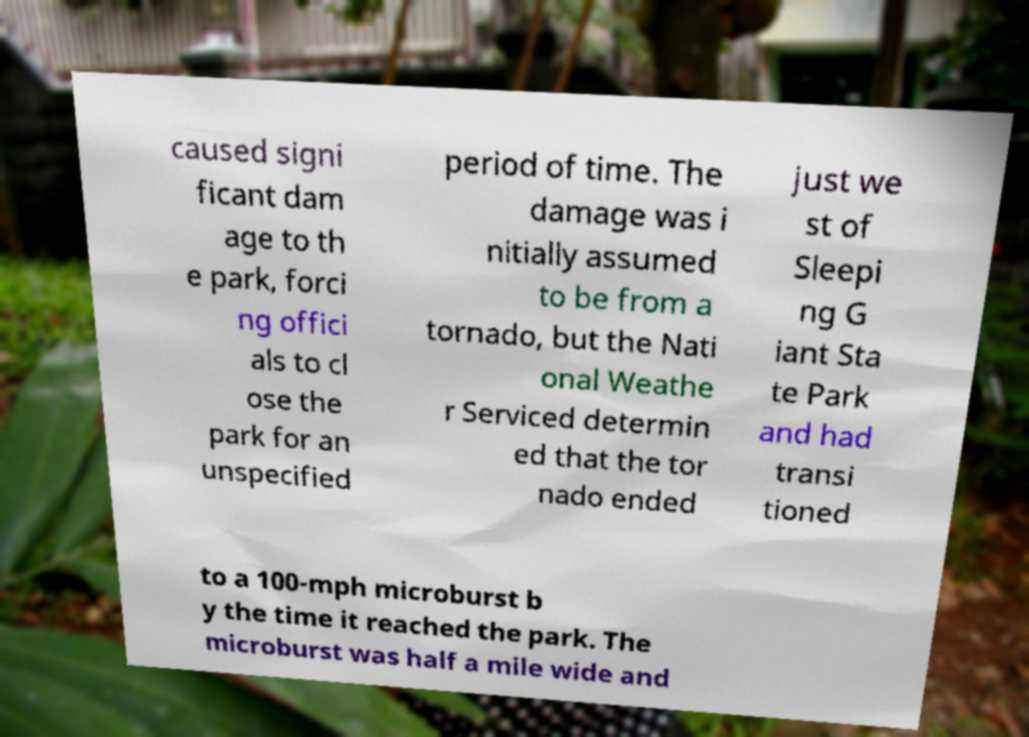What messages or text are displayed in this image? I need them in a readable, typed format. caused signi ficant dam age to th e park, forci ng offici als to cl ose the park for an unspecified period of time. The damage was i nitially assumed to be from a tornado, but the Nati onal Weathe r Serviced determin ed that the tor nado ended just we st of Sleepi ng G iant Sta te Park and had transi tioned to a 100-mph microburst b y the time it reached the park. The microburst was half a mile wide and 